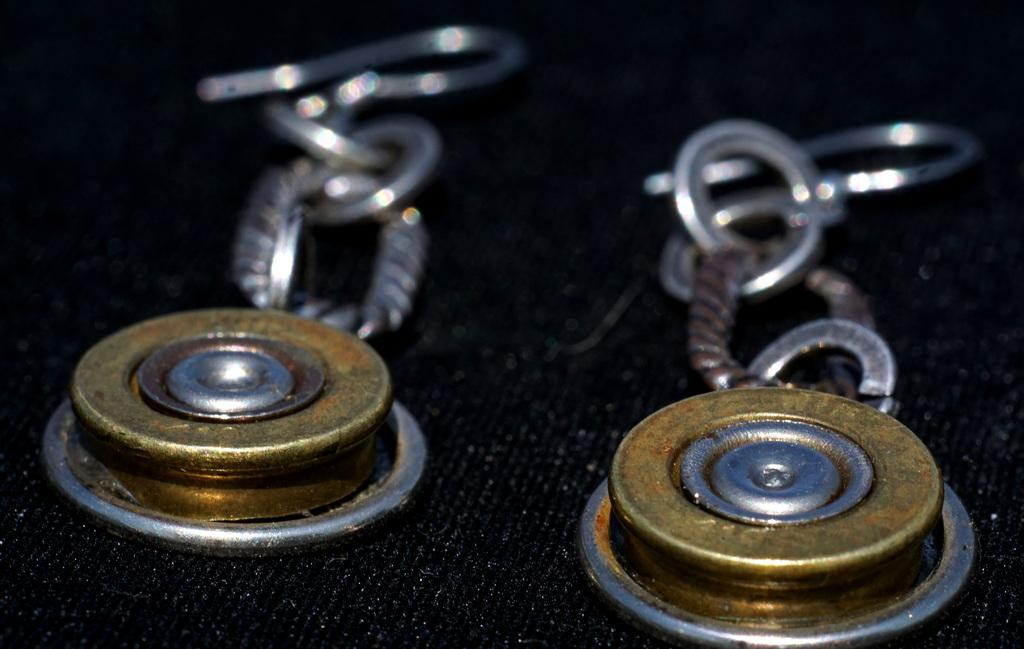What type of accessory is featured in the image? There is a pair of earrings in the image. What color is the background of the image? The background of the image is black. How many points does the cast have on the arm in the image? There is no cast or arm present in the image; it only features a pair of earrings against a black background. 